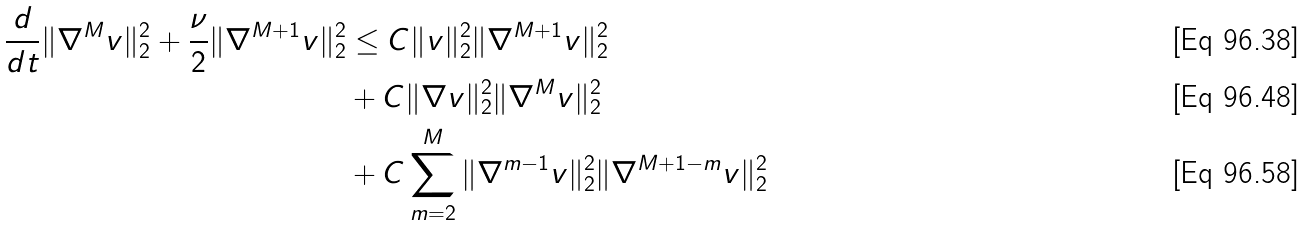<formula> <loc_0><loc_0><loc_500><loc_500>\frac { d } { d t } \| \nabla ^ { M } v \| ^ { 2 } _ { 2 } + \frac { \nu } { 2 } \| \nabla ^ { M + 1 } v \| _ { 2 } ^ { 2 } & \leq C \| v \| _ { 2 } ^ { 2 } \| \nabla ^ { M + 1 } v \| _ { 2 } ^ { 2 } \\ & + C \| \nabla v \| _ { 2 } ^ { 2 } \| \nabla ^ { M } v \| _ { 2 } ^ { 2 } \\ & + C \sum _ { m = 2 } ^ { M } \| \nabla ^ { m - 1 } v \| ^ { 2 } _ { 2 } \| \nabla ^ { M + 1 - m } v \| ^ { 2 } _ { 2 }</formula> 